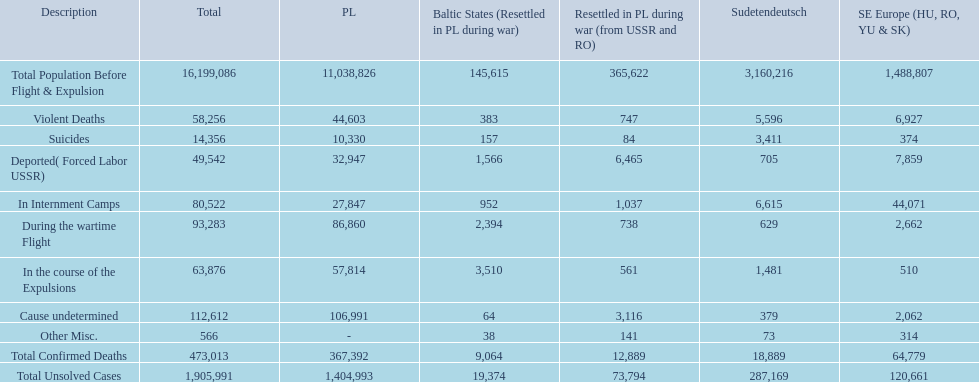How many deaths did the baltic states have in each category? 145,615, 383, 157, 1,566, 952, 2,394, 3,510, 64, 38, 9,064, 19,374. Help me parse the entirety of this table. {'header': ['Description', 'Total', 'PL', 'Baltic States (Resettled in PL during war)', 'Resettled in PL during war (from USSR and RO)', 'Sudetendeutsch', 'SE Europe (HU, RO, YU & SK)'], 'rows': [['Total Population Before Flight & Expulsion', '16,199,086', '11,038,826', '145,615', '365,622', '3,160,216', '1,488,807'], ['Violent Deaths', '58,256', '44,603', '383', '747', '5,596', '6,927'], ['Suicides', '14,356', '10,330', '157', '84', '3,411', '374'], ['Deported( Forced Labor USSR)', '49,542', '32,947', '1,566', '6,465', '705', '7,859'], ['In Internment Camps', '80,522', '27,847', '952', '1,037', '6,615', '44,071'], ['During the wartime Flight', '93,283', '86,860', '2,394', '738', '629', '2,662'], ['In the course of the Expulsions', '63,876', '57,814', '3,510', '561', '1,481', '510'], ['Cause undetermined', '112,612', '106,991', '64', '3,116', '379', '2,062'], ['Other Misc.', '566', '-', '38', '141', '73', '314'], ['Total Confirmed Deaths', '473,013', '367,392', '9,064', '12,889', '18,889', '64,779'], ['Total Unsolved Cases', '1,905,991', '1,404,993', '19,374', '73,794', '287,169', '120,661']]} How many cause undetermined deaths did baltic states have? 64. How many other miscellaneous deaths did baltic states have? 38. Which is higher in deaths, cause undetermined or other miscellaneous? Cause undetermined. 